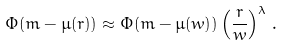<formula> <loc_0><loc_0><loc_500><loc_500>\Phi ( m - \mu ( r ) ) \approx \Phi ( m - \mu ( w ) ) \left ( \frac { r } { w } \right ) ^ { \lambda } \, .</formula> 